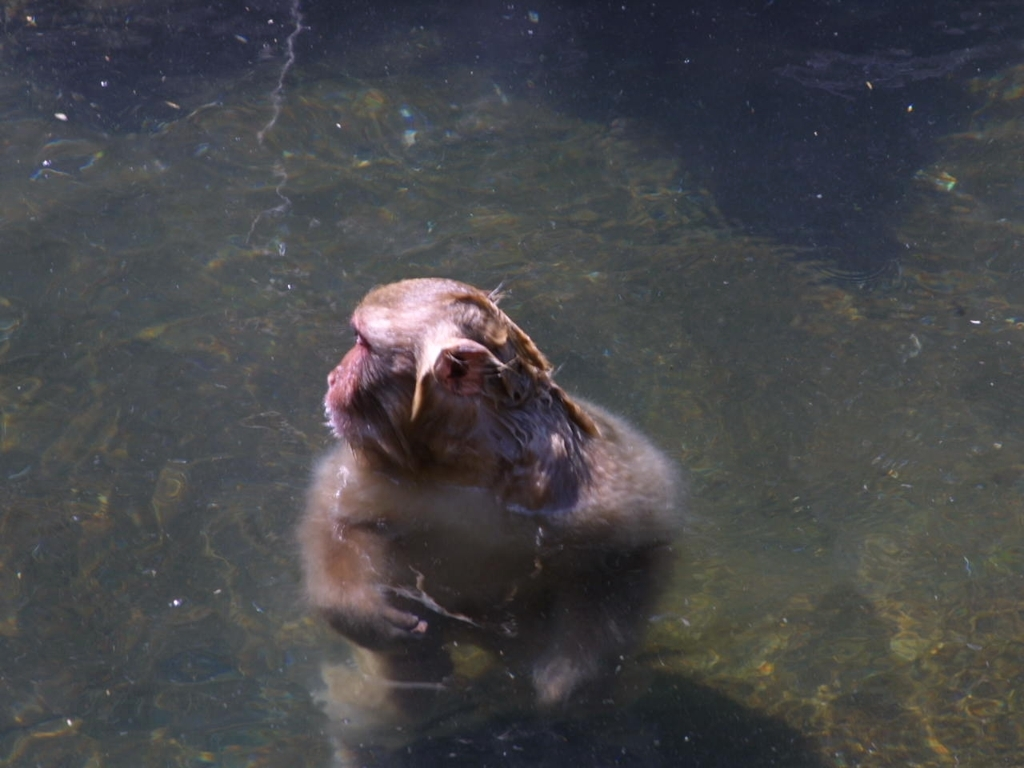Can you tell what the monkey is doing? It's not entirely clear, but the monkey seems to be engaging in a natural behavior, such as foraging, bathing, or possibly cooling off in the water. 